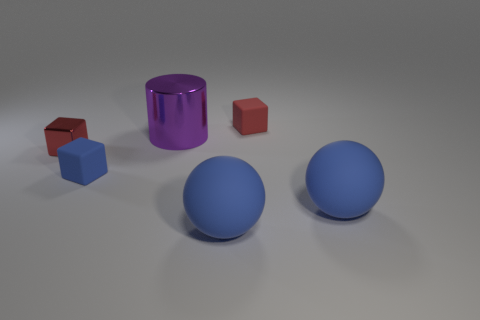There is another thing that is the same color as the tiny metal object; what is its shape?
Make the answer very short. Cube. How big is the blue rubber object that is on the left side of the red rubber object and to the right of the large metallic thing?
Give a very brief answer. Large. What is the color of the matte cube that is the same size as the red rubber thing?
Your answer should be compact. Blue. There is a big cylinder; are there any blue rubber cubes behind it?
Your response must be concise. No. There is a red thing that is left of the purple cylinder; is there a red object on the left side of it?
Offer a terse response. No. Are there fewer tiny red matte objects that are behind the tiny blue block than big metallic things in front of the red metallic cube?
Offer a very short reply. No. Is there anything else that is the same size as the blue cube?
Your answer should be very brief. Yes. The small red matte thing is what shape?
Your response must be concise. Cube. There is a large blue ball to the right of the tiny red matte block; what is its material?
Keep it short and to the point. Rubber. How big is the blue matte thing right of the small rubber object behind the tiny rubber thing that is to the left of the red rubber object?
Give a very brief answer. Large. 